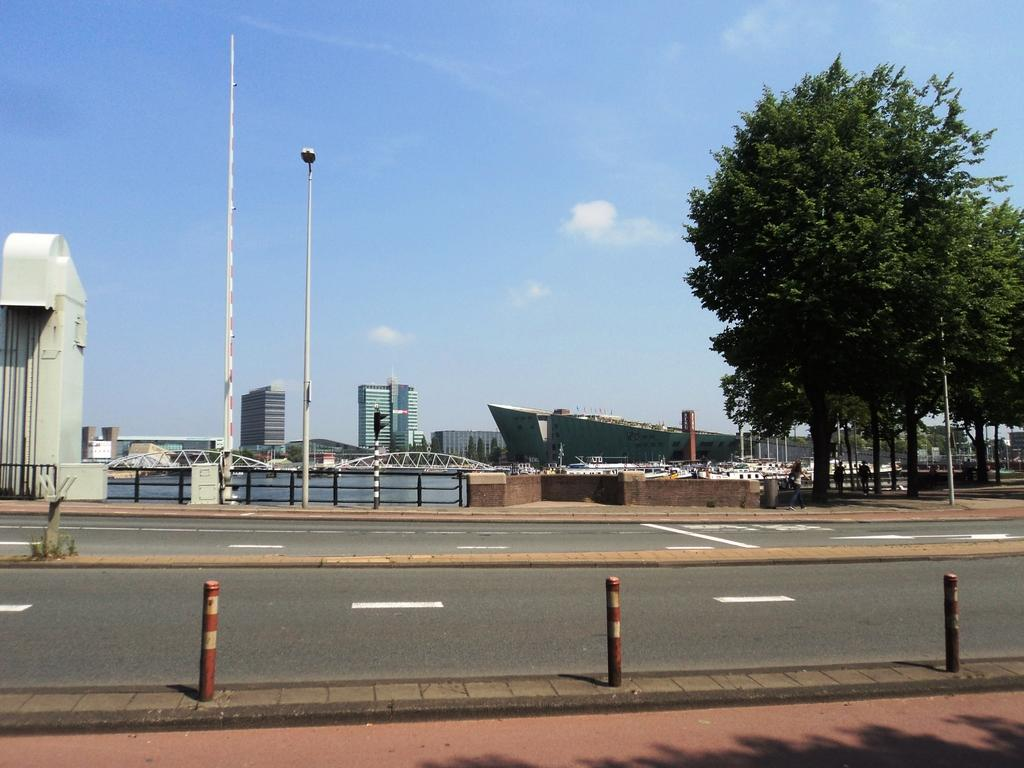What is the main feature in the center of the image? There is a road in the center of the image. What type of natural elements can be seen in the image? There are trees in the image. What type of man-made structures are visible in the background? There are buildings in the background of the image. What safety features are present in the image? There is a railing and safety poles in the image. Where is the pump located in the image? There is no pump present in the image. Can you see a kitten playing with balls in the image? There is no kitten or balls present in the image. 